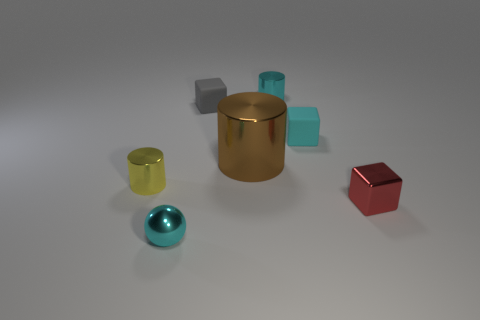Add 2 small spheres. How many objects exist? 9 Subtract all blocks. How many objects are left? 4 Add 2 big metal cylinders. How many big metal cylinders are left? 3 Add 3 cyan shiny cylinders. How many cyan shiny cylinders exist? 4 Subtract 0 red cylinders. How many objects are left? 7 Subtract all small cyan metal spheres. Subtract all large green matte things. How many objects are left? 6 